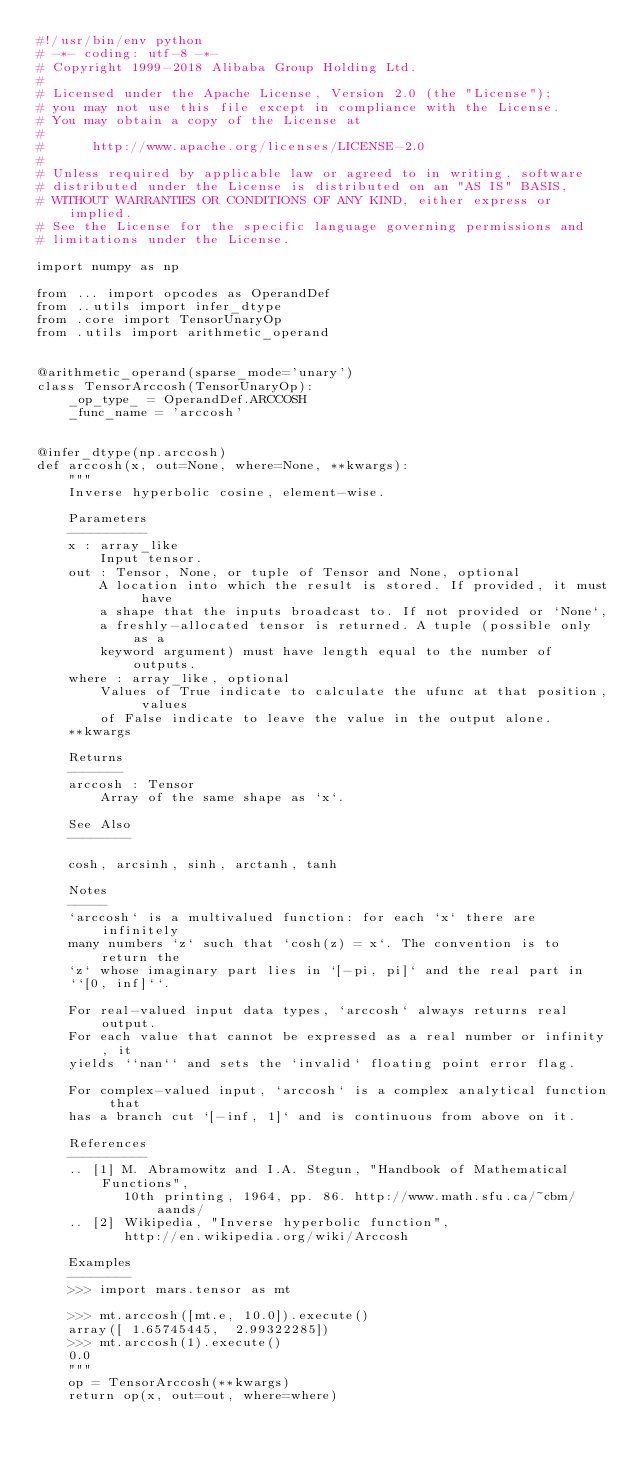Convert code to text. <code><loc_0><loc_0><loc_500><loc_500><_Python_>#!/usr/bin/env python
# -*- coding: utf-8 -*-
# Copyright 1999-2018 Alibaba Group Holding Ltd.
#
# Licensed under the Apache License, Version 2.0 (the "License");
# you may not use this file except in compliance with the License.
# You may obtain a copy of the License at
#
#      http://www.apache.org/licenses/LICENSE-2.0
#
# Unless required by applicable law or agreed to in writing, software
# distributed under the License is distributed on an "AS IS" BASIS,
# WITHOUT WARRANTIES OR CONDITIONS OF ANY KIND, either express or implied.
# See the License for the specific language governing permissions and
# limitations under the License.

import numpy as np

from ... import opcodes as OperandDef
from ..utils import infer_dtype
from .core import TensorUnaryOp
from .utils import arithmetic_operand


@arithmetic_operand(sparse_mode='unary')
class TensorArccosh(TensorUnaryOp):
    _op_type_ = OperandDef.ARCCOSH
    _func_name = 'arccosh'


@infer_dtype(np.arccosh)
def arccosh(x, out=None, where=None, **kwargs):
    """
    Inverse hyperbolic cosine, element-wise.

    Parameters
    ----------
    x : array_like
        Input tensor.
    out : Tensor, None, or tuple of Tensor and None, optional
        A location into which the result is stored. If provided, it must have
        a shape that the inputs broadcast to. If not provided or `None`,
        a freshly-allocated tensor is returned. A tuple (possible only as a
        keyword argument) must have length equal to the number of outputs.
    where : array_like, optional
        Values of True indicate to calculate the ufunc at that position, values
        of False indicate to leave the value in the output alone.
    **kwargs

    Returns
    -------
    arccosh : Tensor
        Array of the same shape as `x`.

    See Also
    --------

    cosh, arcsinh, sinh, arctanh, tanh

    Notes
    -----
    `arccosh` is a multivalued function: for each `x` there are infinitely
    many numbers `z` such that `cosh(z) = x`. The convention is to return the
    `z` whose imaginary part lies in `[-pi, pi]` and the real part in
    ``[0, inf]``.

    For real-valued input data types, `arccosh` always returns real output.
    For each value that cannot be expressed as a real number or infinity, it
    yields ``nan`` and sets the `invalid` floating point error flag.

    For complex-valued input, `arccosh` is a complex analytical function that
    has a branch cut `[-inf, 1]` and is continuous from above on it.

    References
    ----------
    .. [1] M. Abramowitz and I.A. Stegun, "Handbook of Mathematical Functions",
           10th printing, 1964, pp. 86. http://www.math.sfu.ca/~cbm/aands/
    .. [2] Wikipedia, "Inverse hyperbolic function",
           http://en.wikipedia.org/wiki/Arccosh

    Examples
    --------
    >>> import mars.tensor as mt

    >>> mt.arccosh([mt.e, 10.0]).execute()
    array([ 1.65745445,  2.99322285])
    >>> mt.arccosh(1).execute()
    0.0
    """
    op = TensorArccosh(**kwargs)
    return op(x, out=out, where=where)
</code> 